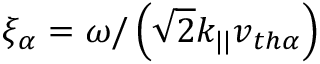<formula> <loc_0><loc_0><loc_500><loc_500>\xi _ { \alpha } = \omega / \left ( \sqrt { 2 } k _ { | | } v _ { t h \alpha } \right )</formula> 